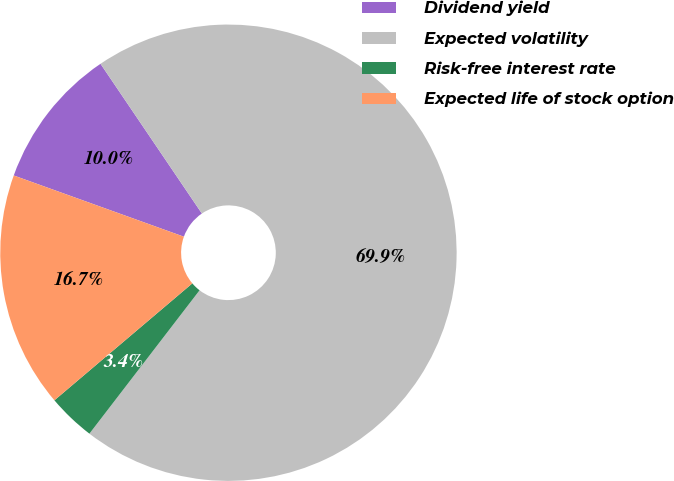Convert chart to OTSL. <chart><loc_0><loc_0><loc_500><loc_500><pie_chart><fcel>Dividend yield<fcel>Expected volatility<fcel>Risk-free interest rate<fcel>Expected life of stock option<nl><fcel>10.03%<fcel>69.9%<fcel>3.38%<fcel>16.69%<nl></chart> 